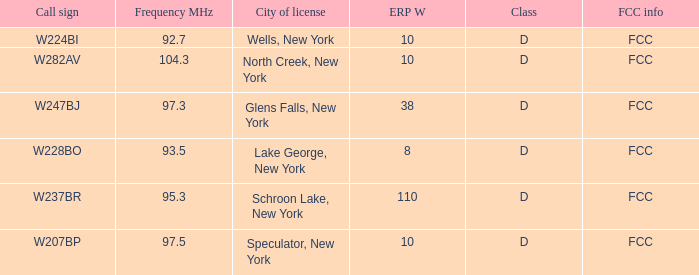Name the ERP W for frequency of 92.7 10.0. 